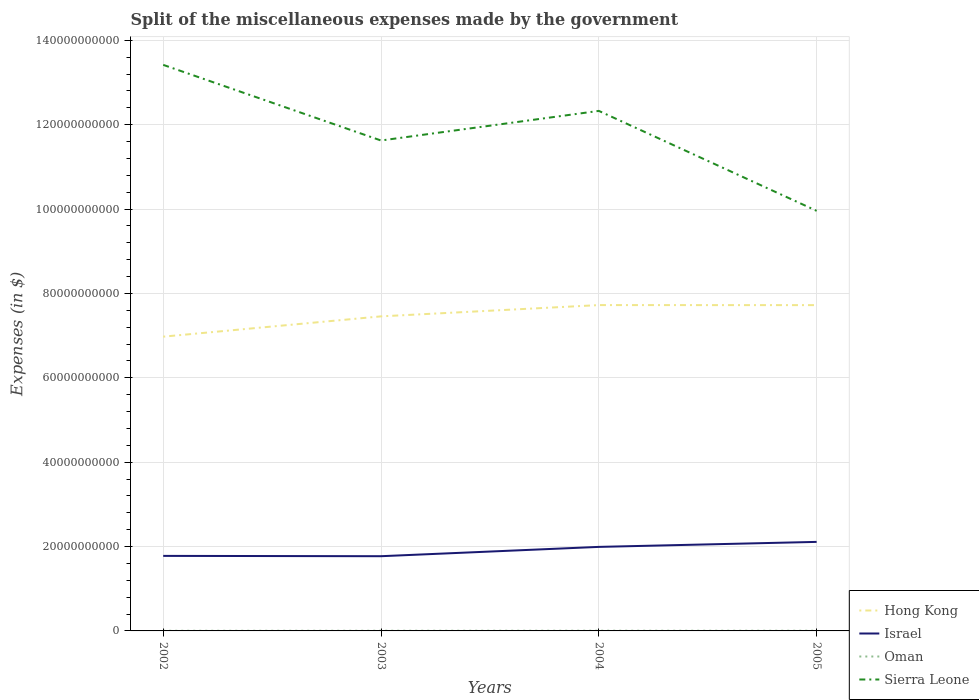How many different coloured lines are there?
Keep it short and to the point. 4. Is the number of lines equal to the number of legend labels?
Offer a very short reply. Yes. Across all years, what is the maximum miscellaneous expenses made by the government in Oman?
Your response must be concise. 3.43e+07. What is the total miscellaneous expenses made by the government in Oman in the graph?
Ensure brevity in your answer.  -2.00e+06. What is the difference between the highest and the second highest miscellaneous expenses made by the government in Hong Kong?
Provide a short and direct response. 7.49e+09. Is the miscellaneous expenses made by the government in Israel strictly greater than the miscellaneous expenses made by the government in Oman over the years?
Keep it short and to the point. No. How many lines are there?
Offer a terse response. 4. What is the difference between two consecutive major ticks on the Y-axis?
Provide a succinct answer. 2.00e+1. Are the values on the major ticks of Y-axis written in scientific E-notation?
Your response must be concise. No. Does the graph contain any zero values?
Your response must be concise. No. Does the graph contain grids?
Give a very brief answer. Yes. How many legend labels are there?
Offer a very short reply. 4. What is the title of the graph?
Keep it short and to the point. Split of the miscellaneous expenses made by the government. Does "Palau" appear as one of the legend labels in the graph?
Your answer should be very brief. No. What is the label or title of the Y-axis?
Provide a short and direct response. Expenses (in $). What is the Expenses (in $) of Hong Kong in 2002?
Give a very brief answer. 6.98e+1. What is the Expenses (in $) of Israel in 2002?
Your response must be concise. 1.78e+1. What is the Expenses (in $) of Oman in 2002?
Your answer should be compact. 3.43e+07. What is the Expenses (in $) of Sierra Leone in 2002?
Your response must be concise. 1.34e+11. What is the Expenses (in $) of Hong Kong in 2003?
Your response must be concise. 7.46e+1. What is the Expenses (in $) of Israel in 2003?
Offer a very short reply. 1.77e+1. What is the Expenses (in $) in Oman in 2003?
Provide a short and direct response. 4.27e+07. What is the Expenses (in $) of Sierra Leone in 2003?
Make the answer very short. 1.16e+11. What is the Expenses (in $) in Hong Kong in 2004?
Provide a succinct answer. 7.72e+1. What is the Expenses (in $) of Israel in 2004?
Give a very brief answer. 1.99e+1. What is the Expenses (in $) in Oman in 2004?
Offer a very short reply. 5.12e+07. What is the Expenses (in $) of Sierra Leone in 2004?
Keep it short and to the point. 1.23e+11. What is the Expenses (in $) in Hong Kong in 2005?
Offer a very short reply. 7.72e+1. What is the Expenses (in $) of Israel in 2005?
Offer a terse response. 2.11e+1. What is the Expenses (in $) of Oman in 2005?
Your response must be concise. 4.47e+07. What is the Expenses (in $) of Sierra Leone in 2005?
Your answer should be very brief. 9.96e+1. Across all years, what is the maximum Expenses (in $) in Hong Kong?
Your answer should be very brief. 7.72e+1. Across all years, what is the maximum Expenses (in $) of Israel?
Your answer should be very brief. 2.11e+1. Across all years, what is the maximum Expenses (in $) of Oman?
Your answer should be very brief. 5.12e+07. Across all years, what is the maximum Expenses (in $) in Sierra Leone?
Provide a succinct answer. 1.34e+11. Across all years, what is the minimum Expenses (in $) in Hong Kong?
Make the answer very short. 6.98e+1. Across all years, what is the minimum Expenses (in $) in Israel?
Your answer should be very brief. 1.77e+1. Across all years, what is the minimum Expenses (in $) in Oman?
Offer a terse response. 3.43e+07. Across all years, what is the minimum Expenses (in $) of Sierra Leone?
Provide a short and direct response. 9.96e+1. What is the total Expenses (in $) in Hong Kong in the graph?
Offer a terse response. 2.99e+11. What is the total Expenses (in $) in Israel in the graph?
Offer a very short reply. 7.65e+1. What is the total Expenses (in $) of Oman in the graph?
Make the answer very short. 1.73e+08. What is the total Expenses (in $) of Sierra Leone in the graph?
Give a very brief answer. 4.73e+11. What is the difference between the Expenses (in $) in Hong Kong in 2002 and that in 2003?
Give a very brief answer. -4.81e+09. What is the difference between the Expenses (in $) in Israel in 2002 and that in 2003?
Your answer should be very brief. 7.46e+07. What is the difference between the Expenses (in $) of Oman in 2002 and that in 2003?
Offer a very short reply. -8.40e+06. What is the difference between the Expenses (in $) in Sierra Leone in 2002 and that in 2003?
Offer a very short reply. 1.79e+1. What is the difference between the Expenses (in $) of Hong Kong in 2002 and that in 2004?
Offer a terse response. -7.49e+09. What is the difference between the Expenses (in $) in Israel in 2002 and that in 2004?
Give a very brief answer. -2.13e+09. What is the difference between the Expenses (in $) in Oman in 2002 and that in 2004?
Provide a succinct answer. -1.69e+07. What is the difference between the Expenses (in $) in Sierra Leone in 2002 and that in 2004?
Give a very brief answer. 1.09e+1. What is the difference between the Expenses (in $) of Hong Kong in 2002 and that in 2005?
Offer a very short reply. -7.48e+09. What is the difference between the Expenses (in $) in Israel in 2002 and that in 2005?
Ensure brevity in your answer.  -3.32e+09. What is the difference between the Expenses (in $) in Oman in 2002 and that in 2005?
Provide a succinct answer. -1.04e+07. What is the difference between the Expenses (in $) of Sierra Leone in 2002 and that in 2005?
Provide a short and direct response. 3.46e+1. What is the difference between the Expenses (in $) in Hong Kong in 2003 and that in 2004?
Make the answer very short. -2.67e+09. What is the difference between the Expenses (in $) of Israel in 2003 and that in 2004?
Your response must be concise. -2.21e+09. What is the difference between the Expenses (in $) of Oman in 2003 and that in 2004?
Offer a terse response. -8.50e+06. What is the difference between the Expenses (in $) in Sierra Leone in 2003 and that in 2004?
Make the answer very short. -7.02e+09. What is the difference between the Expenses (in $) of Hong Kong in 2003 and that in 2005?
Your answer should be compact. -2.66e+09. What is the difference between the Expenses (in $) of Israel in 2003 and that in 2005?
Offer a very short reply. -3.39e+09. What is the difference between the Expenses (in $) in Sierra Leone in 2003 and that in 2005?
Give a very brief answer. 1.67e+1. What is the difference between the Expenses (in $) of Hong Kong in 2004 and that in 2005?
Make the answer very short. 9.00e+06. What is the difference between the Expenses (in $) in Israel in 2004 and that in 2005?
Your answer should be compact. -1.18e+09. What is the difference between the Expenses (in $) in Oman in 2004 and that in 2005?
Give a very brief answer. 6.50e+06. What is the difference between the Expenses (in $) of Sierra Leone in 2004 and that in 2005?
Your answer should be very brief. 2.37e+1. What is the difference between the Expenses (in $) of Hong Kong in 2002 and the Expenses (in $) of Israel in 2003?
Provide a short and direct response. 5.20e+1. What is the difference between the Expenses (in $) in Hong Kong in 2002 and the Expenses (in $) in Oman in 2003?
Give a very brief answer. 6.97e+1. What is the difference between the Expenses (in $) of Hong Kong in 2002 and the Expenses (in $) of Sierra Leone in 2003?
Your answer should be very brief. -4.65e+1. What is the difference between the Expenses (in $) of Israel in 2002 and the Expenses (in $) of Oman in 2003?
Make the answer very short. 1.77e+1. What is the difference between the Expenses (in $) of Israel in 2002 and the Expenses (in $) of Sierra Leone in 2003?
Make the answer very short. -9.85e+1. What is the difference between the Expenses (in $) of Oman in 2002 and the Expenses (in $) of Sierra Leone in 2003?
Make the answer very short. -1.16e+11. What is the difference between the Expenses (in $) of Hong Kong in 2002 and the Expenses (in $) of Israel in 2004?
Give a very brief answer. 4.98e+1. What is the difference between the Expenses (in $) of Hong Kong in 2002 and the Expenses (in $) of Oman in 2004?
Offer a very short reply. 6.97e+1. What is the difference between the Expenses (in $) in Hong Kong in 2002 and the Expenses (in $) in Sierra Leone in 2004?
Provide a short and direct response. -5.35e+1. What is the difference between the Expenses (in $) of Israel in 2002 and the Expenses (in $) of Oman in 2004?
Keep it short and to the point. 1.77e+1. What is the difference between the Expenses (in $) in Israel in 2002 and the Expenses (in $) in Sierra Leone in 2004?
Keep it short and to the point. -1.05e+11. What is the difference between the Expenses (in $) in Oman in 2002 and the Expenses (in $) in Sierra Leone in 2004?
Your response must be concise. -1.23e+11. What is the difference between the Expenses (in $) of Hong Kong in 2002 and the Expenses (in $) of Israel in 2005?
Offer a very short reply. 4.87e+1. What is the difference between the Expenses (in $) in Hong Kong in 2002 and the Expenses (in $) in Oman in 2005?
Your answer should be very brief. 6.97e+1. What is the difference between the Expenses (in $) of Hong Kong in 2002 and the Expenses (in $) of Sierra Leone in 2005?
Provide a succinct answer. -2.98e+1. What is the difference between the Expenses (in $) of Israel in 2002 and the Expenses (in $) of Oman in 2005?
Offer a terse response. 1.77e+1. What is the difference between the Expenses (in $) in Israel in 2002 and the Expenses (in $) in Sierra Leone in 2005?
Give a very brief answer. -8.18e+1. What is the difference between the Expenses (in $) of Oman in 2002 and the Expenses (in $) of Sierra Leone in 2005?
Ensure brevity in your answer.  -9.96e+1. What is the difference between the Expenses (in $) of Hong Kong in 2003 and the Expenses (in $) of Israel in 2004?
Provide a succinct answer. 5.46e+1. What is the difference between the Expenses (in $) in Hong Kong in 2003 and the Expenses (in $) in Oman in 2004?
Your answer should be very brief. 7.45e+1. What is the difference between the Expenses (in $) in Hong Kong in 2003 and the Expenses (in $) in Sierra Leone in 2004?
Make the answer very short. -4.87e+1. What is the difference between the Expenses (in $) of Israel in 2003 and the Expenses (in $) of Oman in 2004?
Your answer should be compact. 1.77e+1. What is the difference between the Expenses (in $) in Israel in 2003 and the Expenses (in $) in Sierra Leone in 2004?
Keep it short and to the point. -1.06e+11. What is the difference between the Expenses (in $) of Oman in 2003 and the Expenses (in $) of Sierra Leone in 2004?
Provide a short and direct response. -1.23e+11. What is the difference between the Expenses (in $) of Hong Kong in 2003 and the Expenses (in $) of Israel in 2005?
Your answer should be very brief. 5.35e+1. What is the difference between the Expenses (in $) in Hong Kong in 2003 and the Expenses (in $) in Oman in 2005?
Offer a terse response. 7.45e+1. What is the difference between the Expenses (in $) of Hong Kong in 2003 and the Expenses (in $) of Sierra Leone in 2005?
Make the answer very short. -2.50e+1. What is the difference between the Expenses (in $) of Israel in 2003 and the Expenses (in $) of Oman in 2005?
Keep it short and to the point. 1.77e+1. What is the difference between the Expenses (in $) of Israel in 2003 and the Expenses (in $) of Sierra Leone in 2005?
Your answer should be compact. -8.19e+1. What is the difference between the Expenses (in $) of Oman in 2003 and the Expenses (in $) of Sierra Leone in 2005?
Keep it short and to the point. -9.95e+1. What is the difference between the Expenses (in $) in Hong Kong in 2004 and the Expenses (in $) in Israel in 2005?
Your response must be concise. 5.61e+1. What is the difference between the Expenses (in $) in Hong Kong in 2004 and the Expenses (in $) in Oman in 2005?
Keep it short and to the point. 7.72e+1. What is the difference between the Expenses (in $) in Hong Kong in 2004 and the Expenses (in $) in Sierra Leone in 2005?
Keep it short and to the point. -2.23e+1. What is the difference between the Expenses (in $) of Israel in 2004 and the Expenses (in $) of Oman in 2005?
Offer a very short reply. 1.99e+1. What is the difference between the Expenses (in $) in Israel in 2004 and the Expenses (in $) in Sierra Leone in 2005?
Provide a short and direct response. -7.97e+1. What is the difference between the Expenses (in $) in Oman in 2004 and the Expenses (in $) in Sierra Leone in 2005?
Ensure brevity in your answer.  -9.95e+1. What is the average Expenses (in $) in Hong Kong per year?
Give a very brief answer. 7.47e+1. What is the average Expenses (in $) of Israel per year?
Provide a short and direct response. 1.91e+1. What is the average Expenses (in $) of Oman per year?
Provide a short and direct response. 4.32e+07. What is the average Expenses (in $) of Sierra Leone per year?
Your response must be concise. 1.18e+11. In the year 2002, what is the difference between the Expenses (in $) in Hong Kong and Expenses (in $) in Israel?
Give a very brief answer. 5.20e+1. In the year 2002, what is the difference between the Expenses (in $) of Hong Kong and Expenses (in $) of Oman?
Your answer should be compact. 6.97e+1. In the year 2002, what is the difference between the Expenses (in $) in Hong Kong and Expenses (in $) in Sierra Leone?
Your answer should be compact. -6.44e+1. In the year 2002, what is the difference between the Expenses (in $) in Israel and Expenses (in $) in Oman?
Your answer should be compact. 1.78e+1. In the year 2002, what is the difference between the Expenses (in $) of Israel and Expenses (in $) of Sierra Leone?
Ensure brevity in your answer.  -1.16e+11. In the year 2002, what is the difference between the Expenses (in $) of Oman and Expenses (in $) of Sierra Leone?
Provide a short and direct response. -1.34e+11. In the year 2003, what is the difference between the Expenses (in $) in Hong Kong and Expenses (in $) in Israel?
Your response must be concise. 5.69e+1. In the year 2003, what is the difference between the Expenses (in $) of Hong Kong and Expenses (in $) of Oman?
Give a very brief answer. 7.45e+1. In the year 2003, what is the difference between the Expenses (in $) of Hong Kong and Expenses (in $) of Sierra Leone?
Offer a terse response. -4.17e+1. In the year 2003, what is the difference between the Expenses (in $) in Israel and Expenses (in $) in Oman?
Give a very brief answer. 1.77e+1. In the year 2003, what is the difference between the Expenses (in $) of Israel and Expenses (in $) of Sierra Leone?
Offer a very short reply. -9.85e+1. In the year 2003, what is the difference between the Expenses (in $) of Oman and Expenses (in $) of Sierra Leone?
Your response must be concise. -1.16e+11. In the year 2004, what is the difference between the Expenses (in $) of Hong Kong and Expenses (in $) of Israel?
Offer a terse response. 5.73e+1. In the year 2004, what is the difference between the Expenses (in $) in Hong Kong and Expenses (in $) in Oman?
Make the answer very short. 7.72e+1. In the year 2004, what is the difference between the Expenses (in $) of Hong Kong and Expenses (in $) of Sierra Leone?
Keep it short and to the point. -4.60e+1. In the year 2004, what is the difference between the Expenses (in $) in Israel and Expenses (in $) in Oman?
Offer a terse response. 1.99e+1. In the year 2004, what is the difference between the Expenses (in $) of Israel and Expenses (in $) of Sierra Leone?
Your answer should be very brief. -1.03e+11. In the year 2004, what is the difference between the Expenses (in $) in Oman and Expenses (in $) in Sierra Leone?
Give a very brief answer. -1.23e+11. In the year 2005, what is the difference between the Expenses (in $) in Hong Kong and Expenses (in $) in Israel?
Make the answer very short. 5.61e+1. In the year 2005, what is the difference between the Expenses (in $) in Hong Kong and Expenses (in $) in Oman?
Keep it short and to the point. 7.72e+1. In the year 2005, what is the difference between the Expenses (in $) of Hong Kong and Expenses (in $) of Sierra Leone?
Keep it short and to the point. -2.24e+1. In the year 2005, what is the difference between the Expenses (in $) of Israel and Expenses (in $) of Oman?
Offer a terse response. 2.11e+1. In the year 2005, what is the difference between the Expenses (in $) in Israel and Expenses (in $) in Sierra Leone?
Your answer should be compact. -7.85e+1. In the year 2005, what is the difference between the Expenses (in $) in Oman and Expenses (in $) in Sierra Leone?
Provide a short and direct response. -9.95e+1. What is the ratio of the Expenses (in $) of Hong Kong in 2002 to that in 2003?
Offer a very short reply. 0.94. What is the ratio of the Expenses (in $) of Oman in 2002 to that in 2003?
Your answer should be very brief. 0.8. What is the ratio of the Expenses (in $) in Sierra Leone in 2002 to that in 2003?
Make the answer very short. 1.15. What is the ratio of the Expenses (in $) in Hong Kong in 2002 to that in 2004?
Offer a terse response. 0.9. What is the ratio of the Expenses (in $) of Israel in 2002 to that in 2004?
Ensure brevity in your answer.  0.89. What is the ratio of the Expenses (in $) in Oman in 2002 to that in 2004?
Your response must be concise. 0.67. What is the ratio of the Expenses (in $) of Sierra Leone in 2002 to that in 2004?
Your response must be concise. 1.09. What is the ratio of the Expenses (in $) of Hong Kong in 2002 to that in 2005?
Your response must be concise. 0.9. What is the ratio of the Expenses (in $) of Israel in 2002 to that in 2005?
Ensure brevity in your answer.  0.84. What is the ratio of the Expenses (in $) in Oman in 2002 to that in 2005?
Make the answer very short. 0.77. What is the ratio of the Expenses (in $) of Sierra Leone in 2002 to that in 2005?
Your response must be concise. 1.35. What is the ratio of the Expenses (in $) of Hong Kong in 2003 to that in 2004?
Provide a short and direct response. 0.97. What is the ratio of the Expenses (in $) of Israel in 2003 to that in 2004?
Make the answer very short. 0.89. What is the ratio of the Expenses (in $) of Oman in 2003 to that in 2004?
Your response must be concise. 0.83. What is the ratio of the Expenses (in $) of Sierra Leone in 2003 to that in 2004?
Ensure brevity in your answer.  0.94. What is the ratio of the Expenses (in $) in Hong Kong in 2003 to that in 2005?
Your answer should be very brief. 0.97. What is the ratio of the Expenses (in $) of Israel in 2003 to that in 2005?
Offer a very short reply. 0.84. What is the ratio of the Expenses (in $) of Oman in 2003 to that in 2005?
Give a very brief answer. 0.96. What is the ratio of the Expenses (in $) in Sierra Leone in 2003 to that in 2005?
Your answer should be compact. 1.17. What is the ratio of the Expenses (in $) of Israel in 2004 to that in 2005?
Your answer should be very brief. 0.94. What is the ratio of the Expenses (in $) of Oman in 2004 to that in 2005?
Provide a succinct answer. 1.15. What is the ratio of the Expenses (in $) in Sierra Leone in 2004 to that in 2005?
Give a very brief answer. 1.24. What is the difference between the highest and the second highest Expenses (in $) of Hong Kong?
Your response must be concise. 9.00e+06. What is the difference between the highest and the second highest Expenses (in $) in Israel?
Your response must be concise. 1.18e+09. What is the difference between the highest and the second highest Expenses (in $) of Oman?
Provide a short and direct response. 6.50e+06. What is the difference between the highest and the second highest Expenses (in $) of Sierra Leone?
Make the answer very short. 1.09e+1. What is the difference between the highest and the lowest Expenses (in $) in Hong Kong?
Offer a terse response. 7.49e+09. What is the difference between the highest and the lowest Expenses (in $) of Israel?
Offer a terse response. 3.39e+09. What is the difference between the highest and the lowest Expenses (in $) in Oman?
Give a very brief answer. 1.69e+07. What is the difference between the highest and the lowest Expenses (in $) of Sierra Leone?
Give a very brief answer. 3.46e+1. 